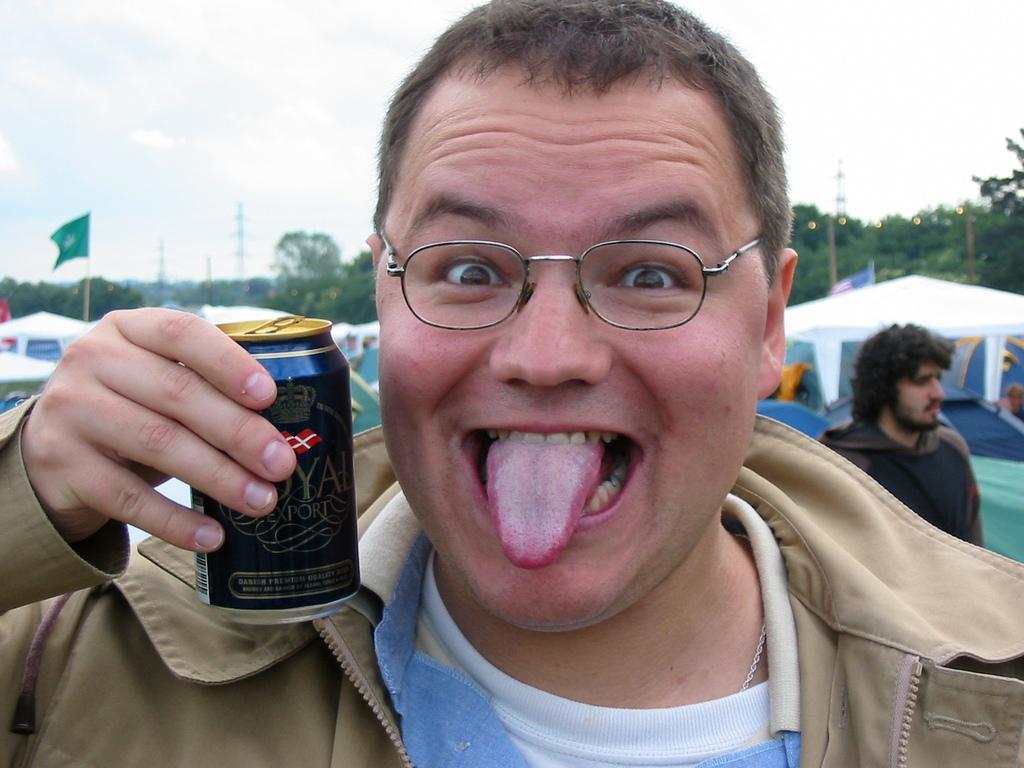Can you describe this image briefly? In this picture we can see a man wore spectacle, jacket holding tin with his hand and in the background we can see tent, some persons, trees, flag, pole, sky with clouds, tower, lights. 